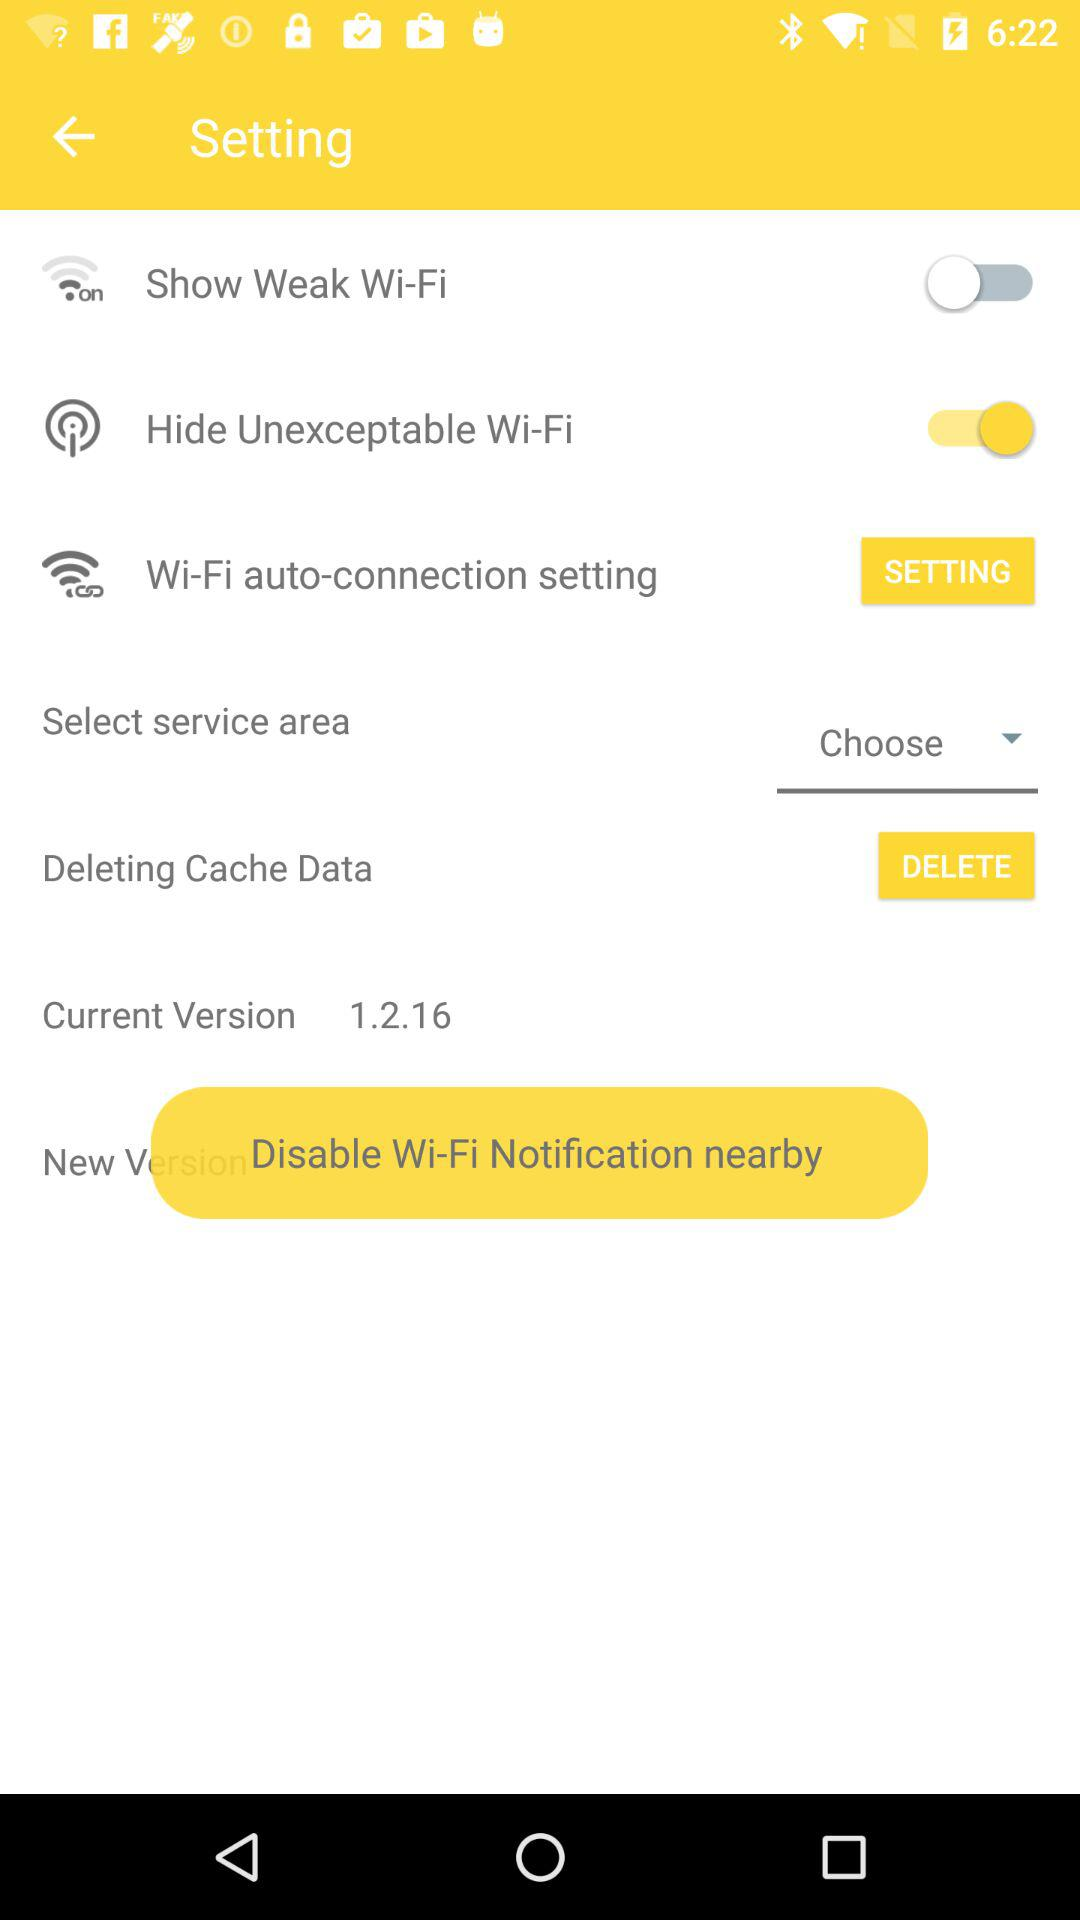What is the current version? The current version is 1.2.16. 